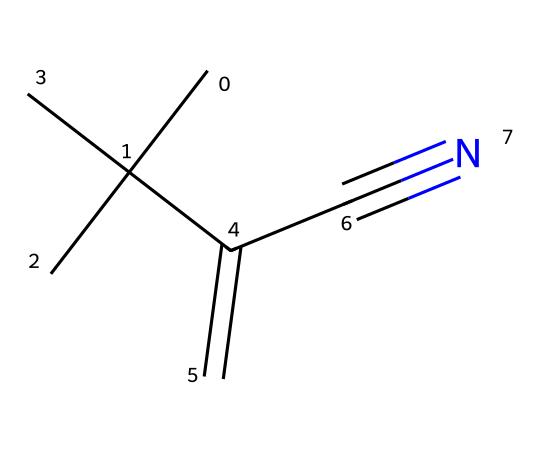What is the molecular formula of this compound? By analyzing the SMILES representation, we identify the carbon (C), hydrogen (H), and nitrogen (N) atoms. The structure contains five carbon atoms, nine hydrogen atoms, and one nitrogen atom, leading us to the molecular formula C5H9N.
Answer: C5H9N How many carbon atoms are present in the compound? The SMILES string reveals five carbon atoms present in the structure, which are indicated by the ‘C’ symbols.
Answer: 5 What type of functional group is represented by the presence of C#N? The C#N indicates the presence of a nitrile functional group, which consists of a carbon triple-bonded to a nitrogen atom. This group is responsible for some of the chemical properties of the compound.
Answer: nitrile What is the degree of unsaturation in the compound? To calculate the degree of unsaturation, we consider the number of double bonds and rings in the molecule. The presence of both a double bond (C=C) and a triple bond (C#N) contributes to the total degree of unsaturation, leading to a degree of 3.
Answer: 3 What is the significance of the branching in the structure? The structure shows a branched configuration (CC(C)(C)), which affects its physical properties, making it more flexible and less likely to crystallize. This branching is typical in synthetic rubber and plastics, like neoprene.
Answer: flexibility What property is enhanced by the nitrile group in neoprene? The presence of the nitrile group in neoprene improves resistance to various chemicals, oils, and environmental factors, making it suitable for polar diving applications.
Answer: chemical resistance 